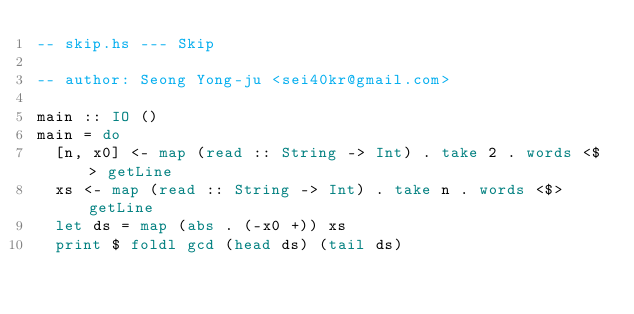<code> <loc_0><loc_0><loc_500><loc_500><_Haskell_>-- skip.hs --- Skip

-- author: Seong Yong-ju <sei40kr@gmail.com>

main :: IO ()
main = do
  [n, x0] <- map (read :: String -> Int) . take 2 . words <$> getLine
  xs <- map (read :: String -> Int) . take n . words <$> getLine
  let ds = map (abs . (-x0 +)) xs
  print $ foldl gcd (head ds) (tail ds)
</code> 